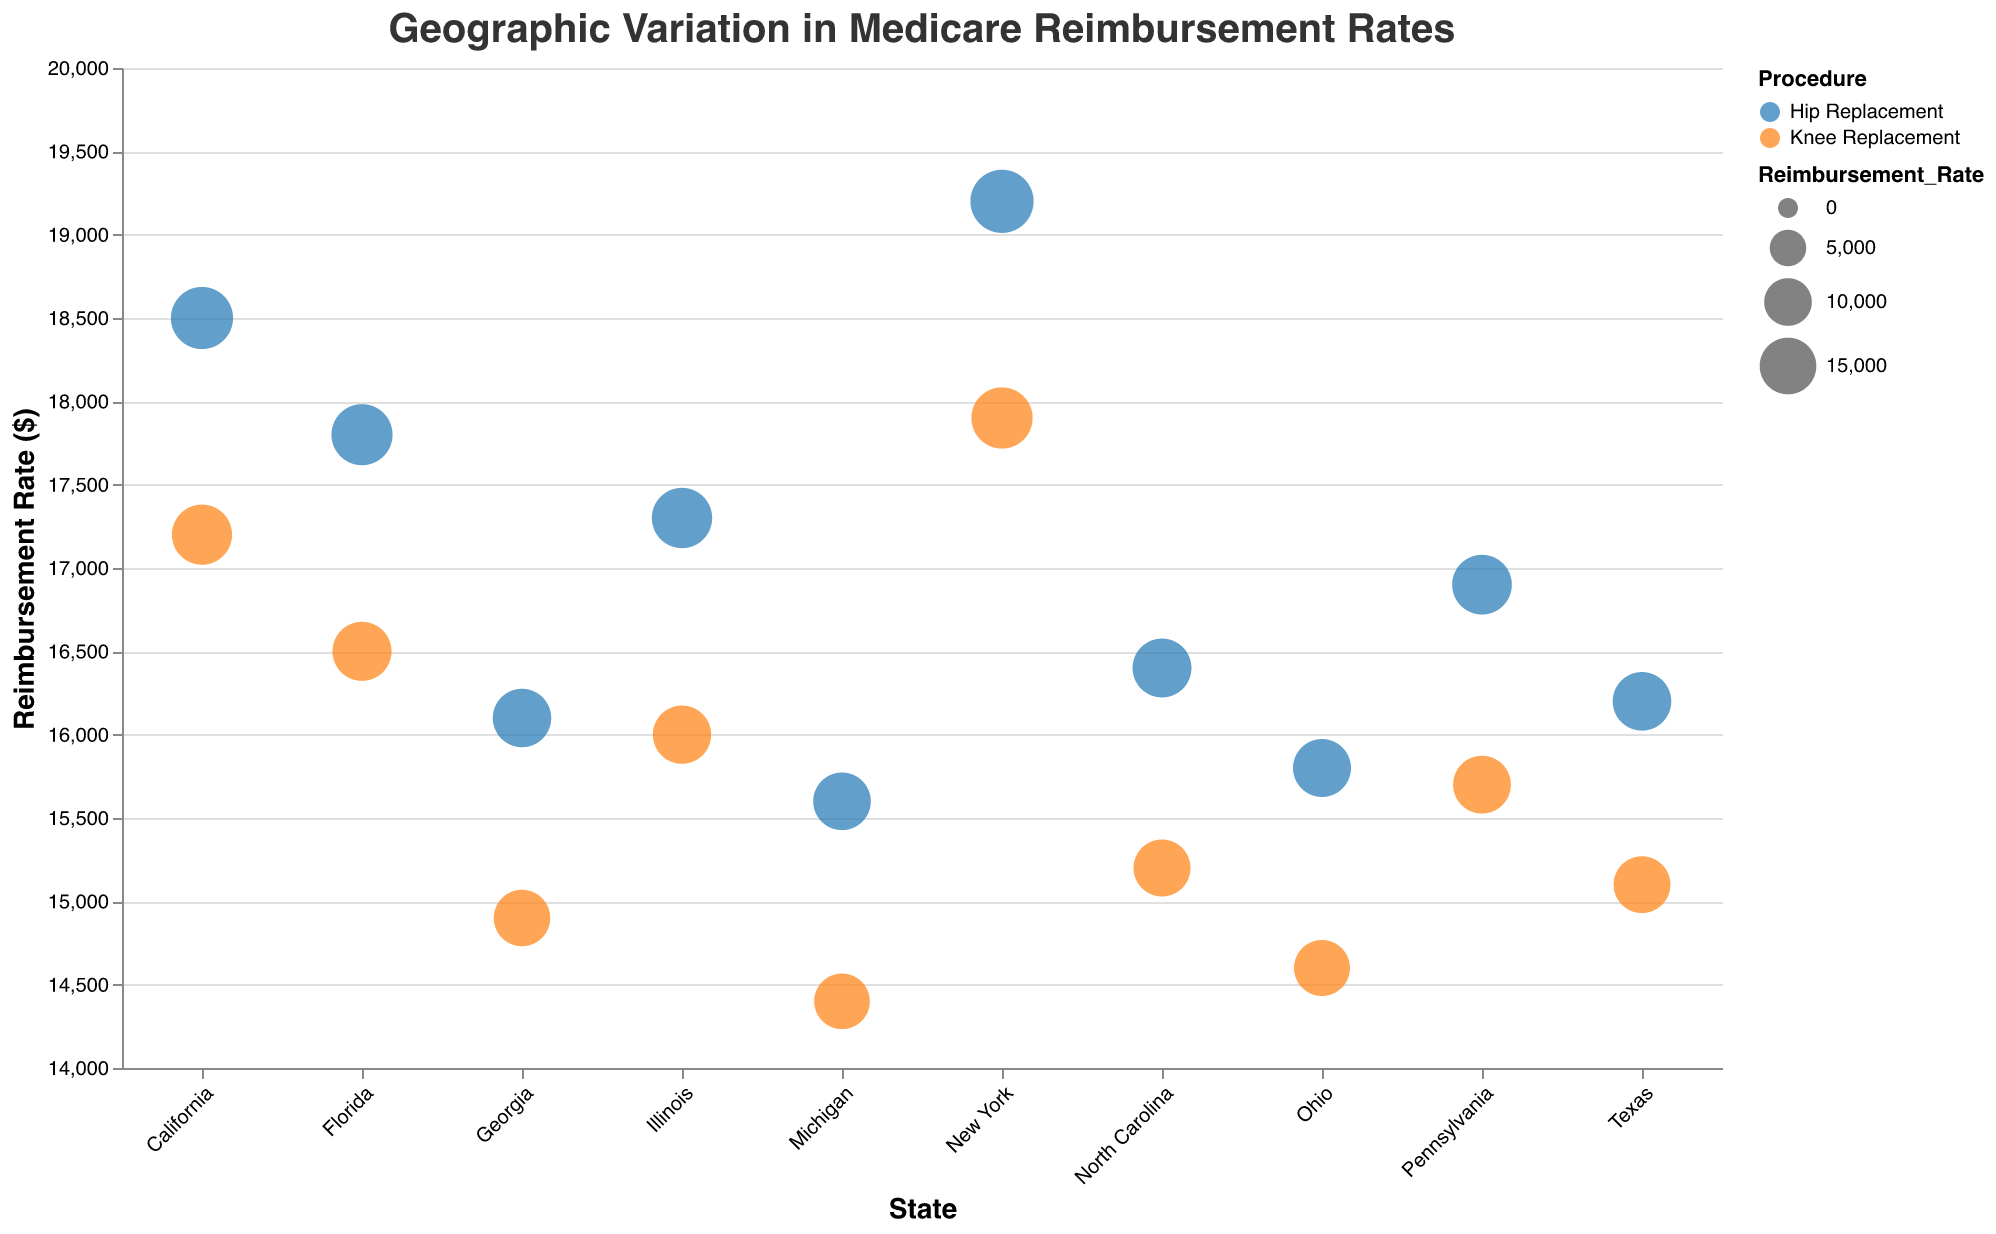What is the title of the figure? The title is displayed at the top of the figure and reads "Geographic Variation in Medicare Reimbursement Rates".
Answer: Geographic Variation in Medicare Reimbursement Rates How many states are represented in this figure? You can count the unique state names along the x-axis to determine the number of states. There are 10 states represented.
Answer: 10 Which procedure, Hip Replacement or Knee Replacement, generally has higher reimbursement rates? By comparing the color-coded points where blue is for Hip Replacement and orange is for Knee Replacement, the blue points (Hip Replacement) seem to have higher y-axis values (Reimbursement Rates) on average than the orange points (Knee Replacement).
Answer: Hip Replacement What is the reimbursement rate for Knee Replacement in Ohio? By locating Ohio on the x-axis and identifying the orange circle representing Knee Replacement, the tooltip shows that the reimbursement rate is $14,600.
Answer: $14,600 Which state has the highest reimbursement rate for both Hip Replacement and Knee Replacement, and what are those rates? By observing the y-axis values (Reimbursement Rates) and color-coded points, New York has the highest reimbursement rates for both procedures. Hip Replacement is $19,200 and Knee Replacement is $17,900.
Answer: New York, $19,200 for Hip Replacement and $17,900 for Knee Replacement Which state's Hip Replacement reimbursement rate is closest to $16,000? By examining the blue dots for Hip Replacement and their proximity to the y-axis value of $16,000, Michigan is the closest with a value of $15,600.
Answer: Michigan What is the range of reimbursement rates for Knee Replacement across all states? The lowest value for Knee Replacement is $14,400 (Michigan) and the highest is $17,900 (New York). The range is the difference between these values: $17,900 - $14,400 = $3,500.
Answer: $3,500 Compare the reimbursement rates for Hip Replacement in California and Texas. Which state has a higher rate and by how much? California's rate is $18,500, while Texas's rate is $16,200. Subtracting these gives $18,500 - $16,200 = $2,300. So, California has a higher rate by $2,300.
Answer: California by $2,300 Calculate the average reimbursement rate for Knee Replacements in the states with rates above $16,000. Which states are included and what is the average rate? States with rates above $16,000 are California ($17,200), Florida ($16,500), and New York ($17,900). The average rate is: ($17,200 + $16,500 + $17,900) / 3 = $17,200.
Answer: $17,200 Are there more states with higher reimbursement rates for Hip Replacement or for Knee Replacement? Count the data points (circles) above a certain threshold (e.g., $16,000) for each color. Hip Replacement points (blue) more frequently appear above $16,000 compared to Knee Replacement points (orange).
Answer: More states have higher rates for Hip Replacement 